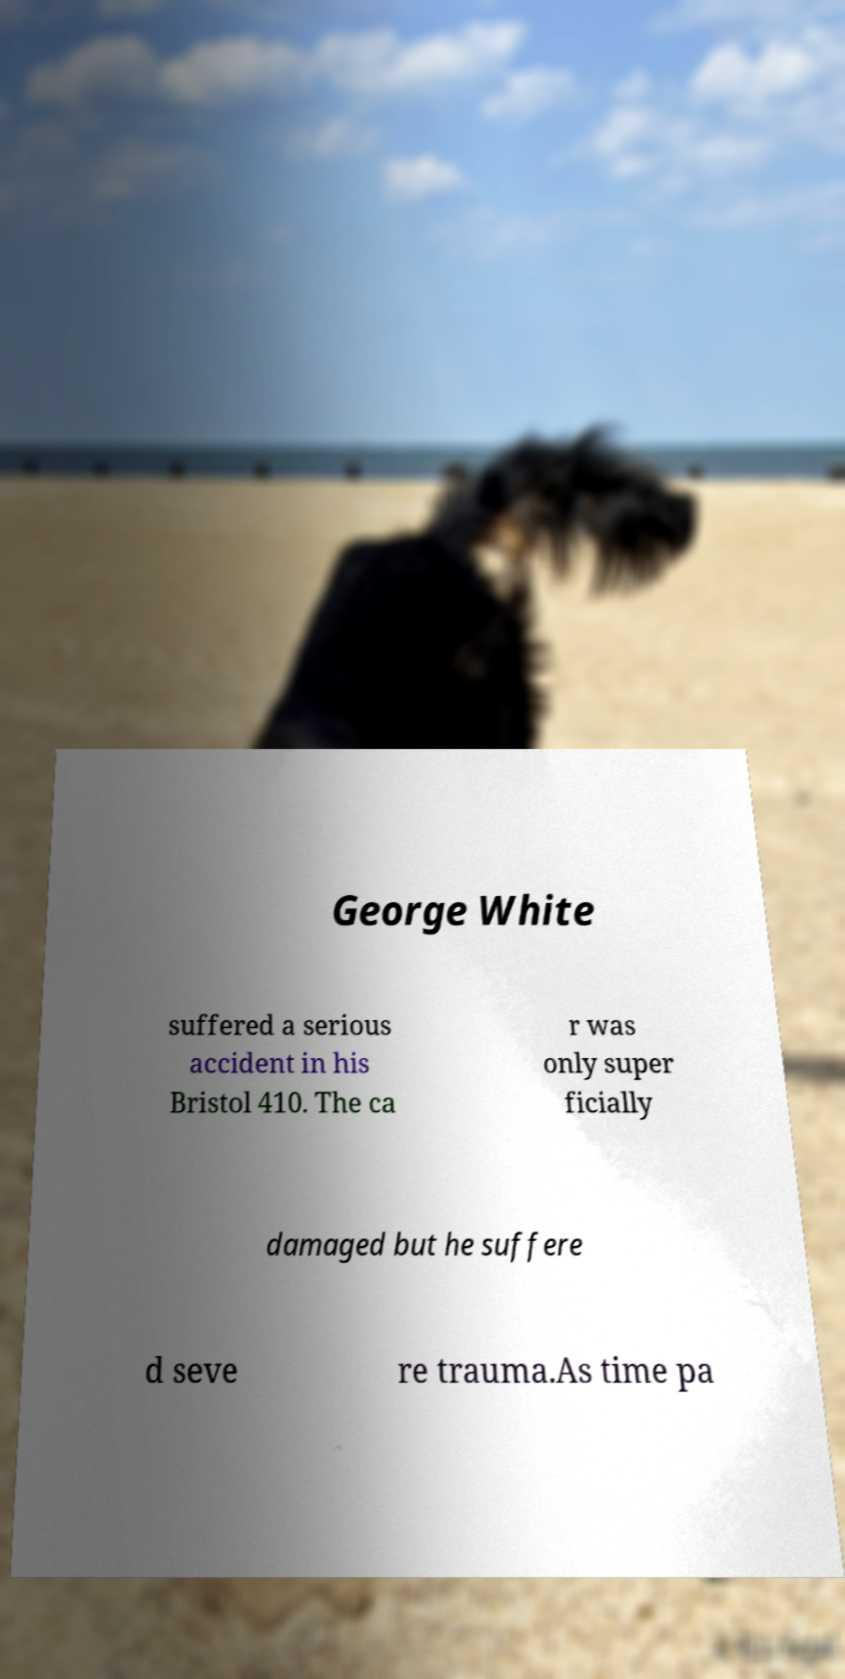What messages or text are displayed in this image? I need them in a readable, typed format. George White suffered a serious accident in his Bristol 410. The ca r was only super ficially damaged but he suffere d seve re trauma.As time pa 